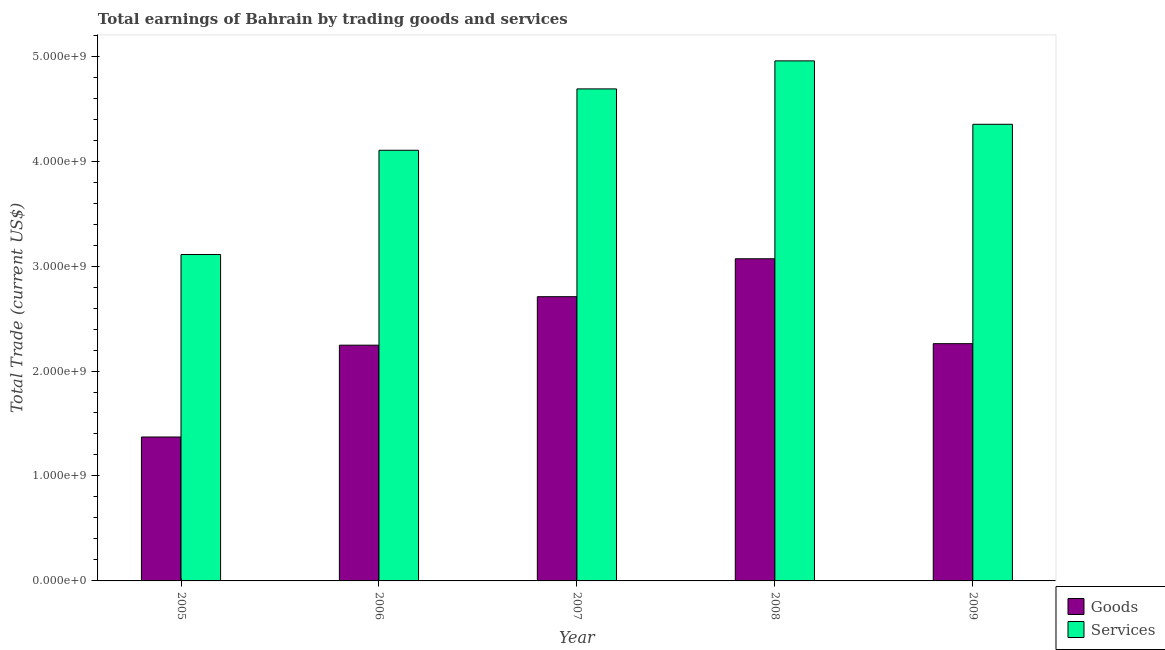How many different coloured bars are there?
Your answer should be compact. 2. How many groups of bars are there?
Offer a very short reply. 5. How many bars are there on the 4th tick from the left?
Provide a short and direct response. 2. What is the amount earned by trading services in 2005?
Provide a short and direct response. 3.11e+09. Across all years, what is the maximum amount earned by trading services?
Your answer should be very brief. 4.96e+09. Across all years, what is the minimum amount earned by trading goods?
Your answer should be compact. 1.37e+09. In which year was the amount earned by trading goods maximum?
Give a very brief answer. 2008. In which year was the amount earned by trading services minimum?
Offer a very short reply. 2005. What is the total amount earned by trading goods in the graph?
Offer a very short reply. 1.17e+1. What is the difference between the amount earned by trading goods in 2005 and that in 2009?
Your answer should be compact. -8.89e+08. What is the difference between the amount earned by trading services in 2005 and the amount earned by trading goods in 2009?
Ensure brevity in your answer.  -1.24e+09. What is the average amount earned by trading goods per year?
Offer a terse response. 2.33e+09. In how many years, is the amount earned by trading goods greater than 2000000000 US$?
Give a very brief answer. 4. What is the ratio of the amount earned by trading services in 2006 to that in 2008?
Provide a short and direct response. 0.83. Is the amount earned by trading goods in 2008 less than that in 2009?
Provide a succinct answer. No. What is the difference between the highest and the second highest amount earned by trading services?
Offer a very short reply. 2.67e+08. What is the difference between the highest and the lowest amount earned by trading services?
Ensure brevity in your answer.  1.85e+09. What does the 1st bar from the left in 2007 represents?
Your answer should be compact. Goods. What does the 2nd bar from the right in 2005 represents?
Keep it short and to the point. Goods. Are all the bars in the graph horizontal?
Offer a terse response. No. What is the difference between two consecutive major ticks on the Y-axis?
Provide a succinct answer. 1.00e+09. Are the values on the major ticks of Y-axis written in scientific E-notation?
Provide a succinct answer. Yes. Does the graph contain any zero values?
Provide a succinct answer. No. Where does the legend appear in the graph?
Your answer should be very brief. Bottom right. How many legend labels are there?
Your answer should be compact. 2. How are the legend labels stacked?
Keep it short and to the point. Vertical. What is the title of the graph?
Make the answer very short. Total earnings of Bahrain by trading goods and services. Does "Tetanus" appear as one of the legend labels in the graph?
Ensure brevity in your answer.  No. What is the label or title of the X-axis?
Ensure brevity in your answer.  Year. What is the label or title of the Y-axis?
Your answer should be compact. Total Trade (current US$). What is the Total Trade (current US$) in Goods in 2005?
Make the answer very short. 1.37e+09. What is the Total Trade (current US$) in Services in 2005?
Your answer should be compact. 3.11e+09. What is the Total Trade (current US$) of Goods in 2006?
Offer a terse response. 2.25e+09. What is the Total Trade (current US$) of Services in 2006?
Provide a succinct answer. 4.10e+09. What is the Total Trade (current US$) in Goods in 2007?
Give a very brief answer. 2.71e+09. What is the Total Trade (current US$) in Services in 2007?
Your answer should be compact. 4.69e+09. What is the Total Trade (current US$) of Goods in 2008?
Your answer should be compact. 3.07e+09. What is the Total Trade (current US$) of Services in 2008?
Provide a succinct answer. 4.96e+09. What is the Total Trade (current US$) of Goods in 2009?
Your answer should be very brief. 2.26e+09. What is the Total Trade (current US$) of Services in 2009?
Provide a short and direct response. 4.35e+09. Across all years, what is the maximum Total Trade (current US$) in Goods?
Make the answer very short. 3.07e+09. Across all years, what is the maximum Total Trade (current US$) of Services?
Ensure brevity in your answer.  4.96e+09. Across all years, what is the minimum Total Trade (current US$) in Goods?
Offer a very short reply. 1.37e+09. Across all years, what is the minimum Total Trade (current US$) of Services?
Your answer should be compact. 3.11e+09. What is the total Total Trade (current US$) of Goods in the graph?
Keep it short and to the point. 1.17e+1. What is the total Total Trade (current US$) of Services in the graph?
Your response must be concise. 2.12e+1. What is the difference between the Total Trade (current US$) of Goods in 2005 and that in 2006?
Provide a succinct answer. -8.75e+08. What is the difference between the Total Trade (current US$) in Services in 2005 and that in 2006?
Offer a very short reply. -9.93e+08. What is the difference between the Total Trade (current US$) in Goods in 2005 and that in 2007?
Provide a short and direct response. -1.34e+09. What is the difference between the Total Trade (current US$) in Services in 2005 and that in 2007?
Make the answer very short. -1.58e+09. What is the difference between the Total Trade (current US$) of Goods in 2005 and that in 2008?
Offer a very short reply. -1.70e+09. What is the difference between the Total Trade (current US$) in Services in 2005 and that in 2008?
Provide a short and direct response. -1.85e+09. What is the difference between the Total Trade (current US$) of Goods in 2005 and that in 2009?
Offer a very short reply. -8.89e+08. What is the difference between the Total Trade (current US$) in Services in 2005 and that in 2009?
Offer a terse response. -1.24e+09. What is the difference between the Total Trade (current US$) of Goods in 2006 and that in 2007?
Provide a succinct answer. -4.62e+08. What is the difference between the Total Trade (current US$) of Services in 2006 and that in 2007?
Your answer should be very brief. -5.85e+08. What is the difference between the Total Trade (current US$) in Goods in 2006 and that in 2008?
Ensure brevity in your answer.  -8.23e+08. What is the difference between the Total Trade (current US$) of Services in 2006 and that in 2008?
Offer a terse response. -8.52e+08. What is the difference between the Total Trade (current US$) in Goods in 2006 and that in 2009?
Provide a short and direct response. -1.44e+07. What is the difference between the Total Trade (current US$) in Services in 2006 and that in 2009?
Give a very brief answer. -2.48e+08. What is the difference between the Total Trade (current US$) of Goods in 2007 and that in 2008?
Make the answer very short. -3.61e+08. What is the difference between the Total Trade (current US$) of Services in 2007 and that in 2008?
Give a very brief answer. -2.67e+08. What is the difference between the Total Trade (current US$) in Goods in 2007 and that in 2009?
Offer a terse response. 4.47e+08. What is the difference between the Total Trade (current US$) in Services in 2007 and that in 2009?
Keep it short and to the point. 3.37e+08. What is the difference between the Total Trade (current US$) of Goods in 2008 and that in 2009?
Keep it short and to the point. 8.09e+08. What is the difference between the Total Trade (current US$) in Services in 2008 and that in 2009?
Offer a terse response. 6.04e+08. What is the difference between the Total Trade (current US$) in Goods in 2005 and the Total Trade (current US$) in Services in 2006?
Provide a short and direct response. -2.73e+09. What is the difference between the Total Trade (current US$) of Goods in 2005 and the Total Trade (current US$) of Services in 2007?
Keep it short and to the point. -3.32e+09. What is the difference between the Total Trade (current US$) of Goods in 2005 and the Total Trade (current US$) of Services in 2008?
Provide a short and direct response. -3.58e+09. What is the difference between the Total Trade (current US$) in Goods in 2005 and the Total Trade (current US$) in Services in 2009?
Offer a terse response. -2.98e+09. What is the difference between the Total Trade (current US$) of Goods in 2006 and the Total Trade (current US$) of Services in 2007?
Provide a short and direct response. -2.44e+09. What is the difference between the Total Trade (current US$) in Goods in 2006 and the Total Trade (current US$) in Services in 2008?
Give a very brief answer. -2.71e+09. What is the difference between the Total Trade (current US$) in Goods in 2006 and the Total Trade (current US$) in Services in 2009?
Ensure brevity in your answer.  -2.10e+09. What is the difference between the Total Trade (current US$) in Goods in 2007 and the Total Trade (current US$) in Services in 2008?
Make the answer very short. -2.25e+09. What is the difference between the Total Trade (current US$) in Goods in 2007 and the Total Trade (current US$) in Services in 2009?
Ensure brevity in your answer.  -1.64e+09. What is the difference between the Total Trade (current US$) in Goods in 2008 and the Total Trade (current US$) in Services in 2009?
Offer a terse response. -1.28e+09. What is the average Total Trade (current US$) in Goods per year?
Make the answer very short. 2.33e+09. What is the average Total Trade (current US$) in Services per year?
Offer a very short reply. 4.24e+09. In the year 2005, what is the difference between the Total Trade (current US$) of Goods and Total Trade (current US$) of Services?
Offer a terse response. -1.74e+09. In the year 2006, what is the difference between the Total Trade (current US$) of Goods and Total Trade (current US$) of Services?
Provide a succinct answer. -1.86e+09. In the year 2007, what is the difference between the Total Trade (current US$) of Goods and Total Trade (current US$) of Services?
Keep it short and to the point. -1.98e+09. In the year 2008, what is the difference between the Total Trade (current US$) of Goods and Total Trade (current US$) of Services?
Offer a very short reply. -1.89e+09. In the year 2009, what is the difference between the Total Trade (current US$) in Goods and Total Trade (current US$) in Services?
Offer a very short reply. -2.09e+09. What is the ratio of the Total Trade (current US$) in Goods in 2005 to that in 2006?
Offer a very short reply. 0.61. What is the ratio of the Total Trade (current US$) in Services in 2005 to that in 2006?
Ensure brevity in your answer.  0.76. What is the ratio of the Total Trade (current US$) of Goods in 2005 to that in 2007?
Keep it short and to the point. 0.51. What is the ratio of the Total Trade (current US$) of Services in 2005 to that in 2007?
Your response must be concise. 0.66. What is the ratio of the Total Trade (current US$) of Goods in 2005 to that in 2008?
Make the answer very short. 0.45. What is the ratio of the Total Trade (current US$) of Services in 2005 to that in 2008?
Your answer should be very brief. 0.63. What is the ratio of the Total Trade (current US$) of Goods in 2005 to that in 2009?
Your answer should be very brief. 0.61. What is the ratio of the Total Trade (current US$) of Services in 2005 to that in 2009?
Your response must be concise. 0.71. What is the ratio of the Total Trade (current US$) of Goods in 2006 to that in 2007?
Your response must be concise. 0.83. What is the ratio of the Total Trade (current US$) of Services in 2006 to that in 2007?
Provide a succinct answer. 0.88. What is the ratio of the Total Trade (current US$) of Goods in 2006 to that in 2008?
Keep it short and to the point. 0.73. What is the ratio of the Total Trade (current US$) of Services in 2006 to that in 2008?
Provide a short and direct response. 0.83. What is the ratio of the Total Trade (current US$) of Services in 2006 to that in 2009?
Keep it short and to the point. 0.94. What is the ratio of the Total Trade (current US$) of Goods in 2007 to that in 2008?
Ensure brevity in your answer.  0.88. What is the ratio of the Total Trade (current US$) in Services in 2007 to that in 2008?
Ensure brevity in your answer.  0.95. What is the ratio of the Total Trade (current US$) of Goods in 2007 to that in 2009?
Keep it short and to the point. 1.2. What is the ratio of the Total Trade (current US$) of Services in 2007 to that in 2009?
Ensure brevity in your answer.  1.08. What is the ratio of the Total Trade (current US$) in Goods in 2008 to that in 2009?
Your answer should be very brief. 1.36. What is the ratio of the Total Trade (current US$) of Services in 2008 to that in 2009?
Your answer should be very brief. 1.14. What is the difference between the highest and the second highest Total Trade (current US$) in Goods?
Your answer should be compact. 3.61e+08. What is the difference between the highest and the second highest Total Trade (current US$) in Services?
Offer a very short reply. 2.67e+08. What is the difference between the highest and the lowest Total Trade (current US$) of Goods?
Offer a very short reply. 1.70e+09. What is the difference between the highest and the lowest Total Trade (current US$) in Services?
Offer a very short reply. 1.85e+09. 